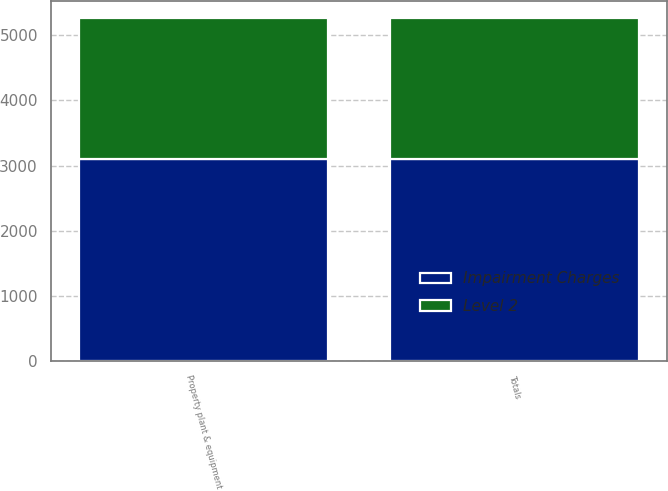<chart> <loc_0><loc_0><loc_500><loc_500><stacked_bar_chart><ecel><fcel>Property plant & equipment<fcel>Totals<nl><fcel>Level 2<fcel>2172<fcel>2172<nl><fcel>Impairment Charges<fcel>3095<fcel>3095<nl></chart> 